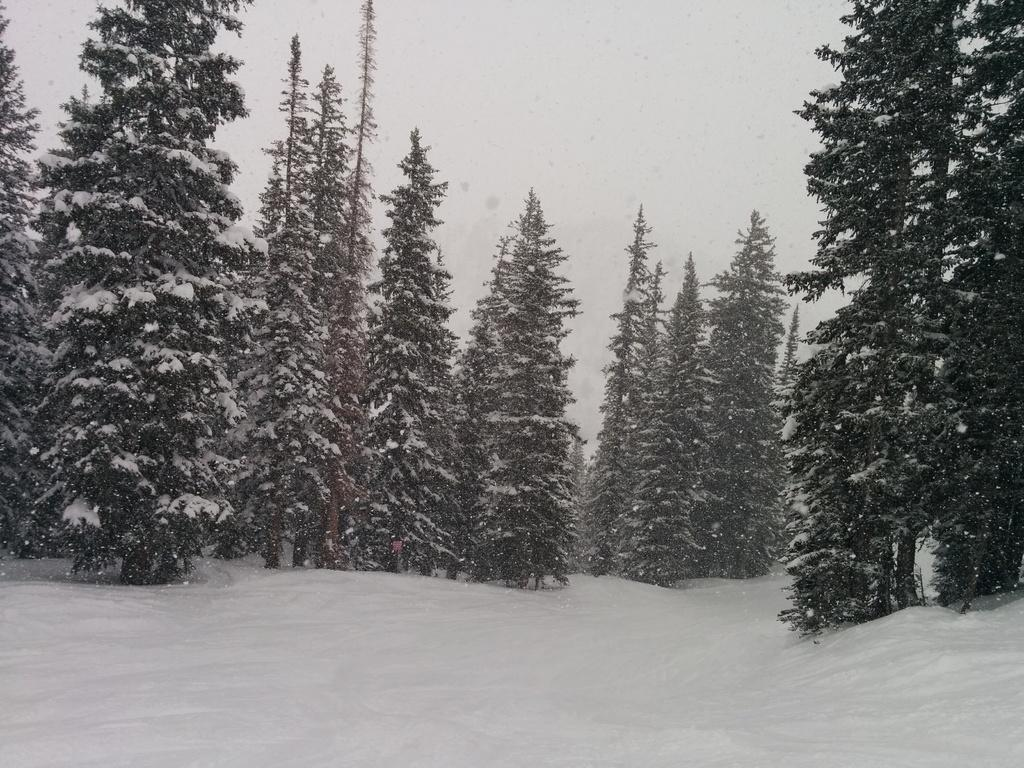Where was the image taken? The image was clicked outside the city. What is the primary feature in the foreground of the image? There is a lot of snow in the foreground of the image. What can be seen in the center of the image? There are trees in the center of the image. What is visible in the background of the image? There is a sky visible in the background of the image. How is the aunt related to the trees in the image? There is no mention of an aunt in the image, so it is not possible to determine any relationship between the aunt and the trees. 